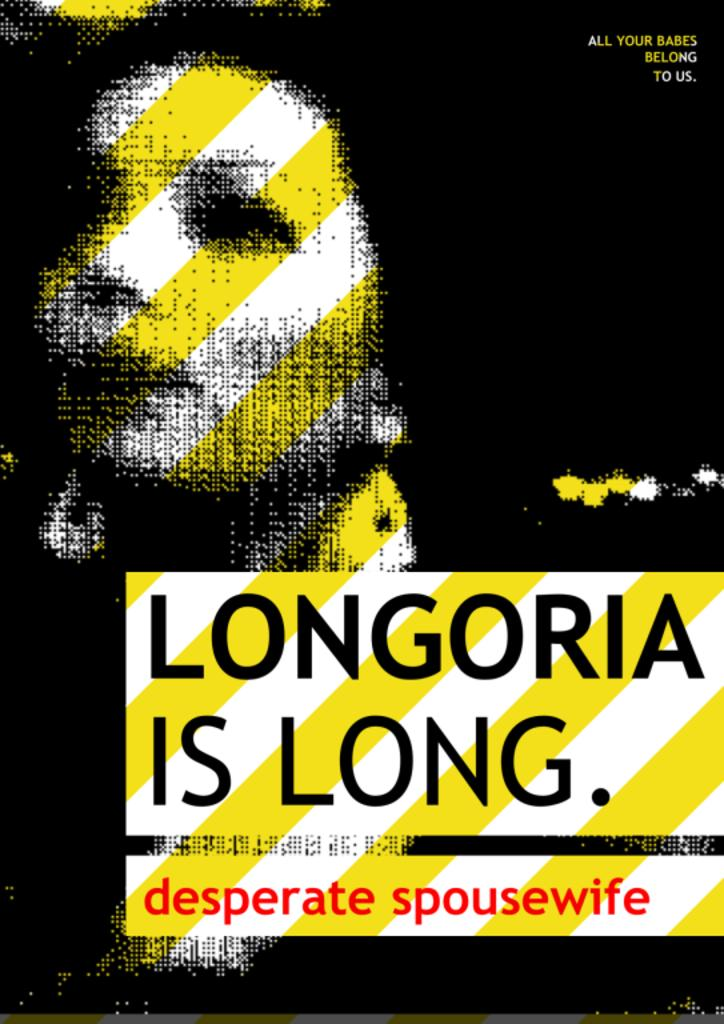<image>
Offer a succinct explanation of the picture presented. a yellow and white sign with Longoria on it 